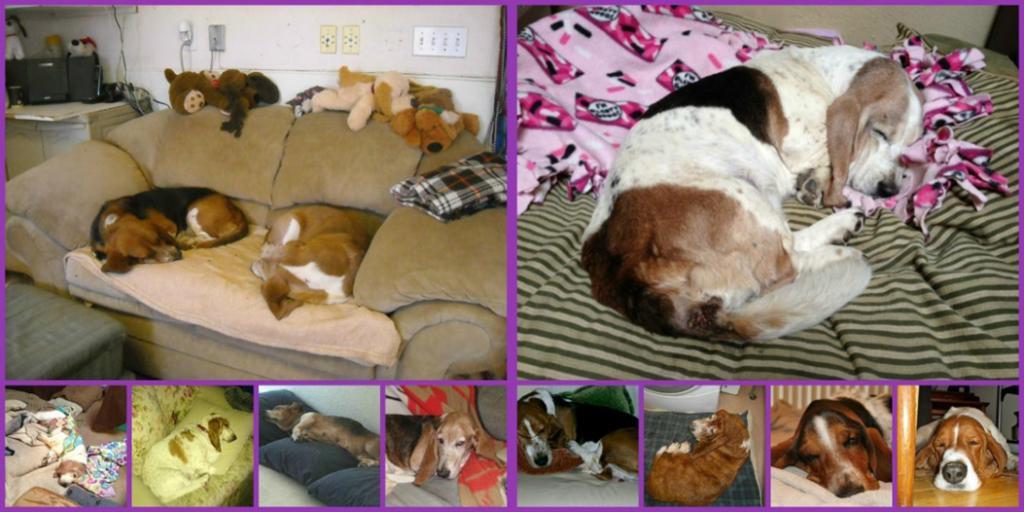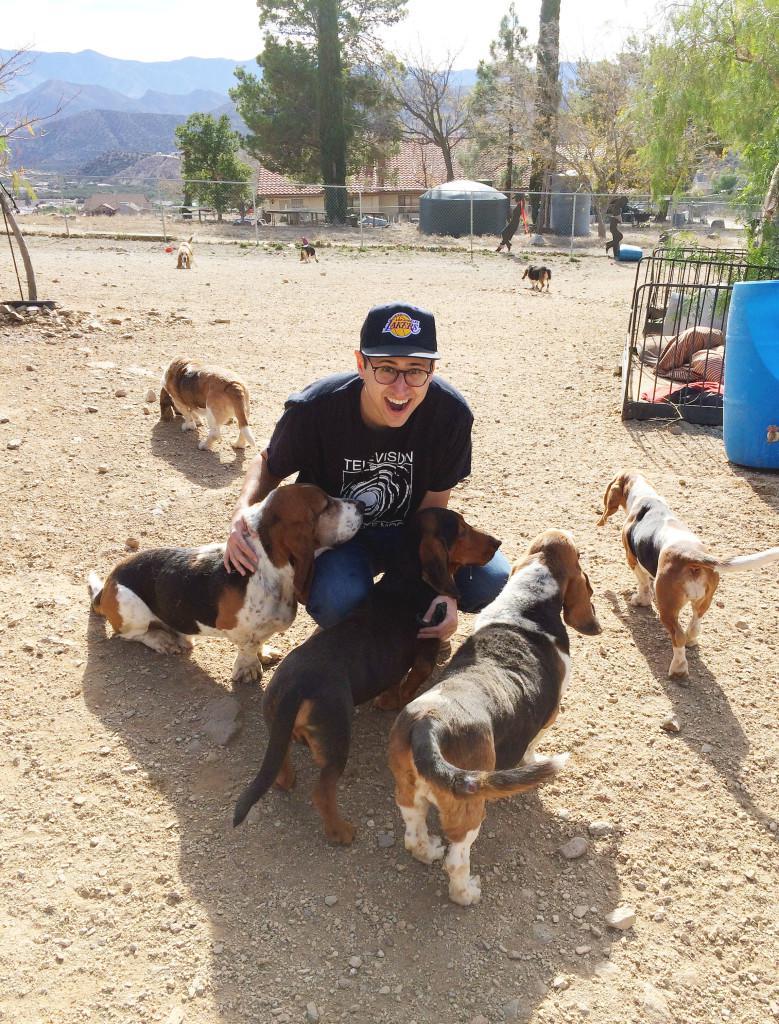The first image is the image on the left, the second image is the image on the right. For the images displayed, is the sentence "An image shows a person behind a wash bucket containing a basset hound." factually correct? Answer yes or no. No. The first image is the image on the left, the second image is the image on the right. For the images displayed, is the sentence "A person in a tank top is bathing a dog outside." factually correct? Answer yes or no. No. 